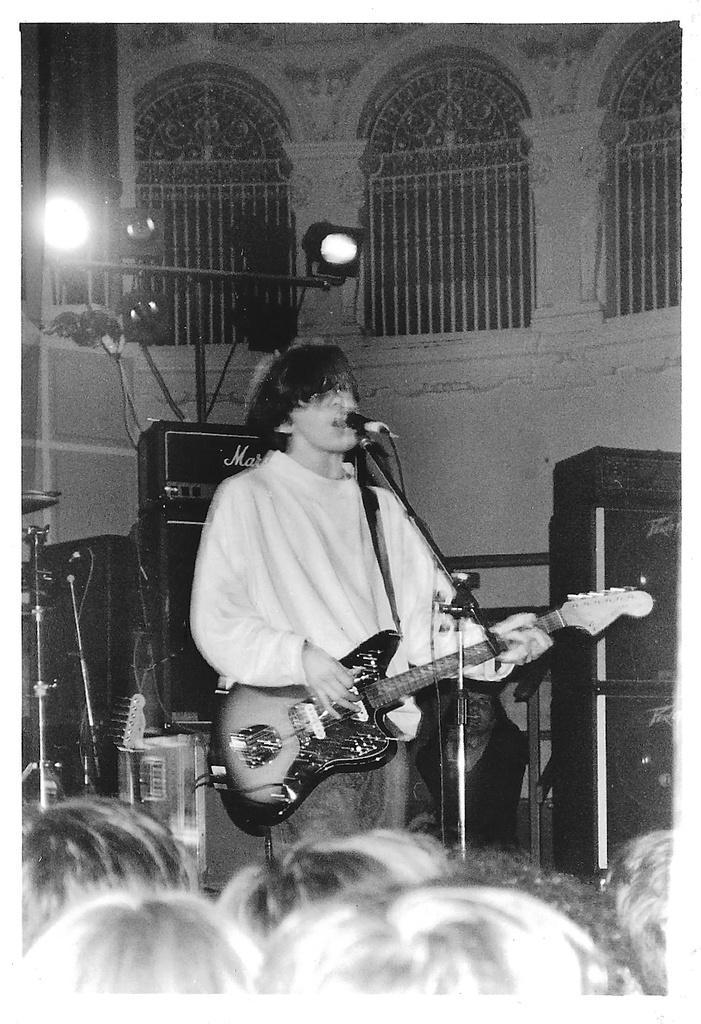Describe this image in one or two sentences. A person wearing a white t shirt is holding a guitar and playing. He is singing also. In front of him there is a mic and mic stand. There are speakers and lights in the background. There are railings in the background. 